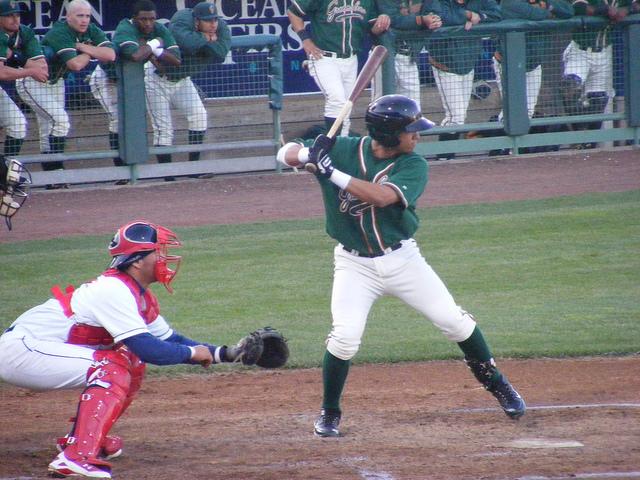Are there any blues shirts?
Write a very short answer. No. What kind of ball is the man holding?
Concise answer only. Baseball. What sport is being played?
Concise answer only. Baseball. What is the color of the men pants?
Concise answer only. White. How many of these people are professional baseball players?
Answer briefly. 11. Where is their coach?
Give a very brief answer. Dugout. Is this a professional game?
Give a very brief answer. Yes. What color is the batter's socks?
Give a very brief answer. Green. What color is the batting helmet?
Concise answer only. Black. How many people have face guards on?
Concise answer only. 1. Is this little league?
Give a very brief answer. No. What game are these men playing?
Concise answer only. Baseball. If the ball gets by the batter, will it be a ball or a strike?
Write a very short answer. Strike. What type of surface are they playing on?
Short answer required. Dirt. Is the batter using a wood or aluminum bat?
Write a very short answer. Wood. 